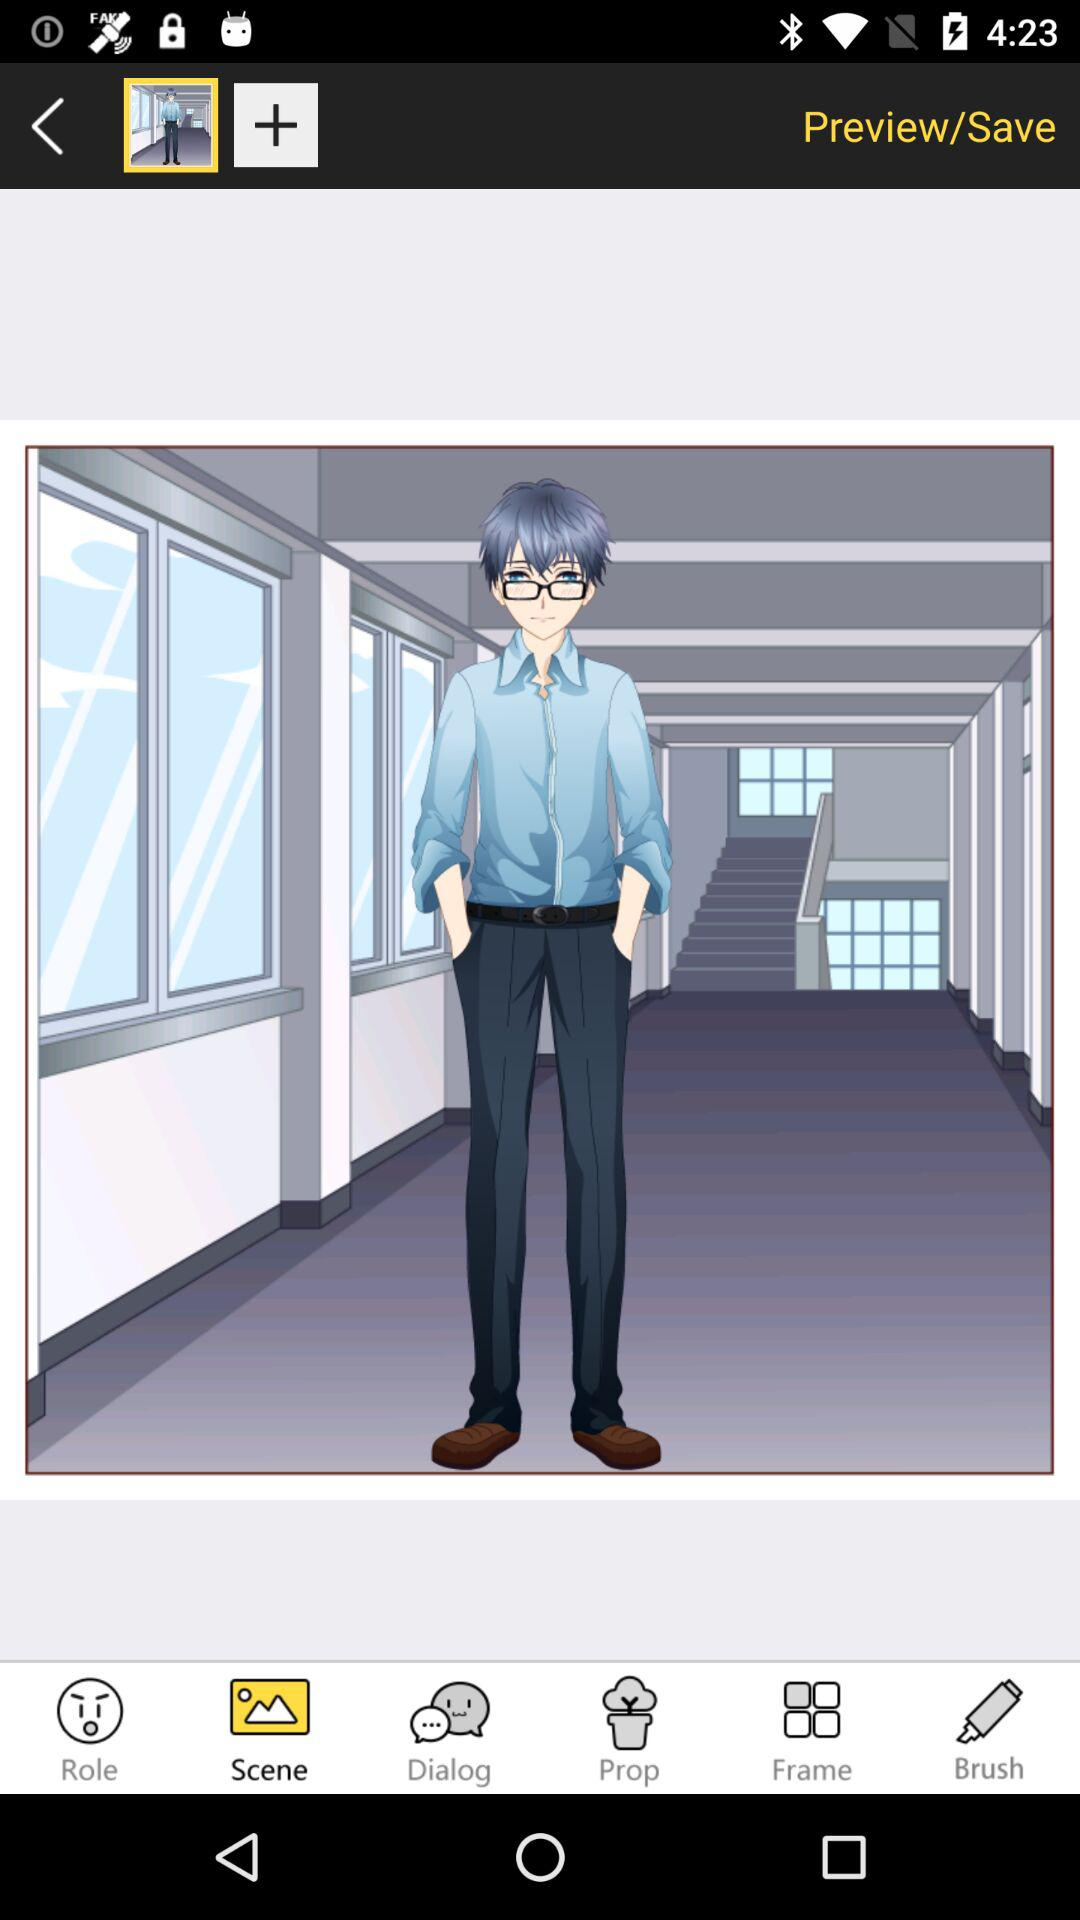Which tab has been selected? The tab that has been selected is "Scene". 